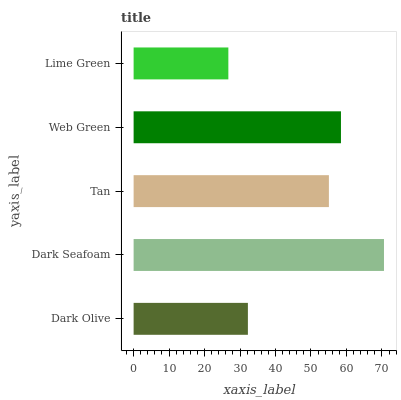Is Lime Green the minimum?
Answer yes or no. Yes. Is Dark Seafoam the maximum?
Answer yes or no. Yes. Is Tan the minimum?
Answer yes or no. No. Is Tan the maximum?
Answer yes or no. No. Is Dark Seafoam greater than Tan?
Answer yes or no. Yes. Is Tan less than Dark Seafoam?
Answer yes or no. Yes. Is Tan greater than Dark Seafoam?
Answer yes or no. No. Is Dark Seafoam less than Tan?
Answer yes or no. No. Is Tan the high median?
Answer yes or no. Yes. Is Tan the low median?
Answer yes or no. Yes. Is Lime Green the high median?
Answer yes or no. No. Is Dark Olive the low median?
Answer yes or no. No. 